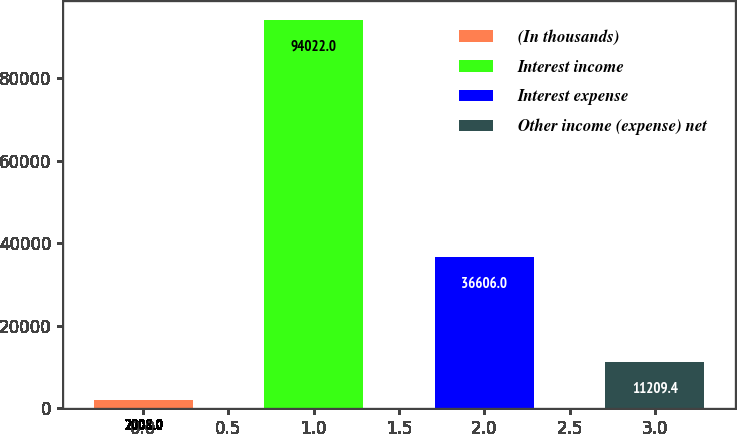Convert chart. <chart><loc_0><loc_0><loc_500><loc_500><bar_chart><fcel>(In thousands)<fcel>Interest income<fcel>Interest expense<fcel>Other income (expense) net<nl><fcel>2008<fcel>94022<fcel>36606<fcel>11209.4<nl></chart> 